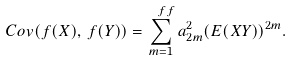Convert formula to latex. <formula><loc_0><loc_0><loc_500><loc_500>C o v ( f ( X ) , \, f ( Y ) ) = \sum _ { m = 1 } ^ { \ f f } a _ { 2 m } ^ { 2 } ( E ( X Y ) ) ^ { 2 m } .</formula> 